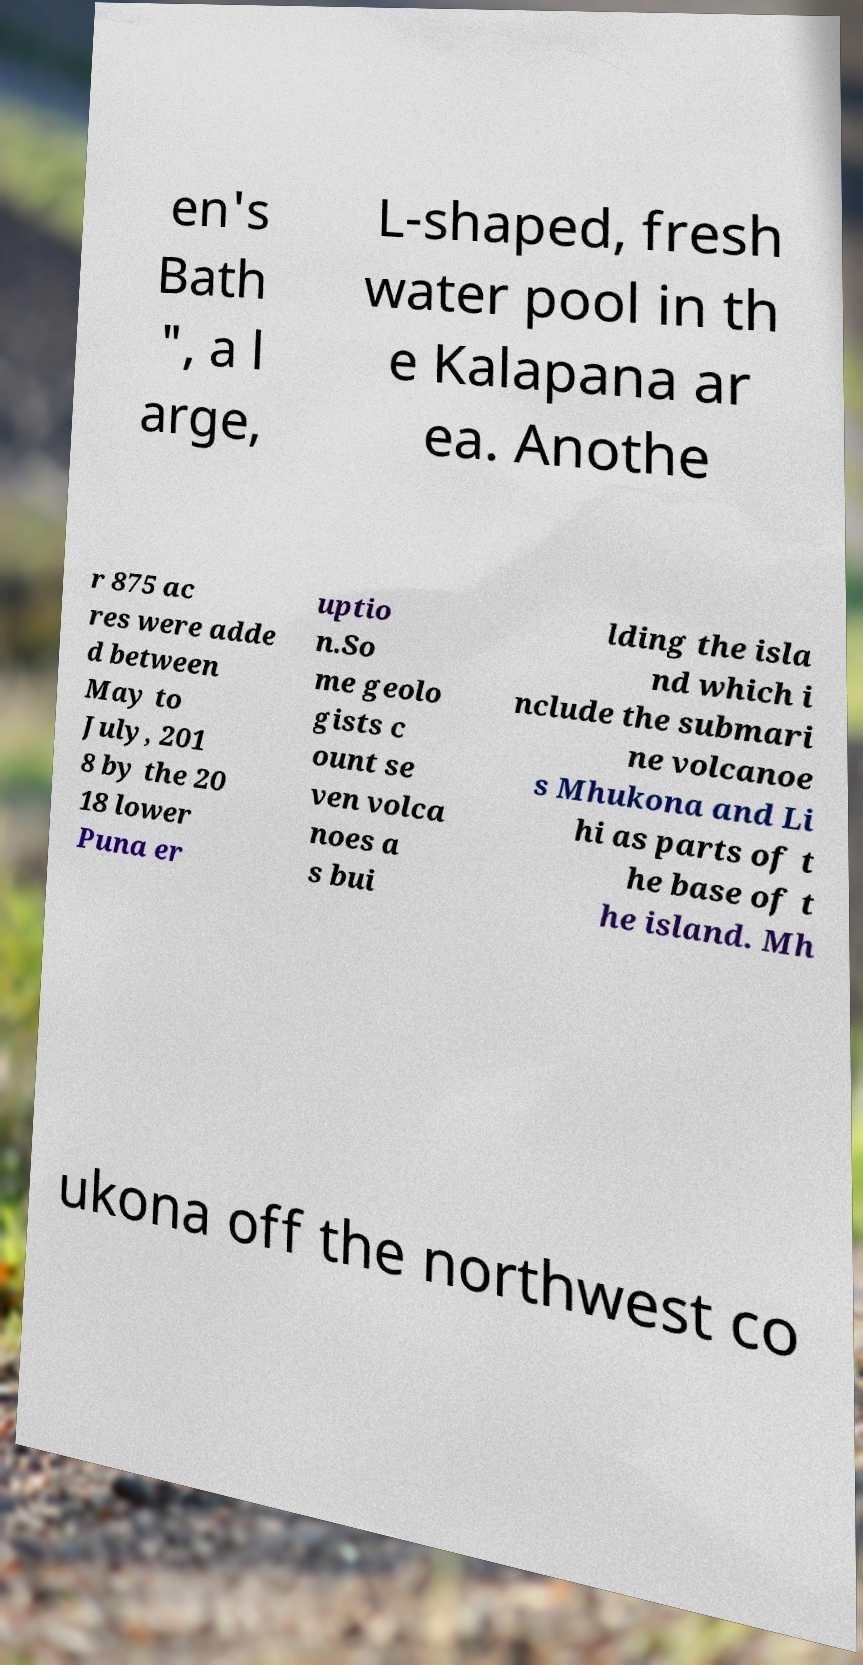Can you read and provide the text displayed in the image?This photo seems to have some interesting text. Can you extract and type it out for me? en's Bath ", a l arge, L-shaped, fresh water pool in th e Kalapana ar ea. Anothe r 875 ac res were adde d between May to July, 201 8 by the 20 18 lower Puna er uptio n.So me geolo gists c ount se ven volca noes a s bui lding the isla nd which i nclude the submari ne volcanoe s Mhukona and Li hi as parts of t he base of t he island. Mh ukona off the northwest co 